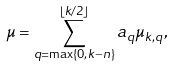Convert formula to latex. <formula><loc_0><loc_0><loc_500><loc_500>\mu = \sum _ { q = \max \{ 0 , k - n \} } ^ { \lfloor k / 2 \rfloor } a _ { q } \mu _ { k , q } ,</formula> 